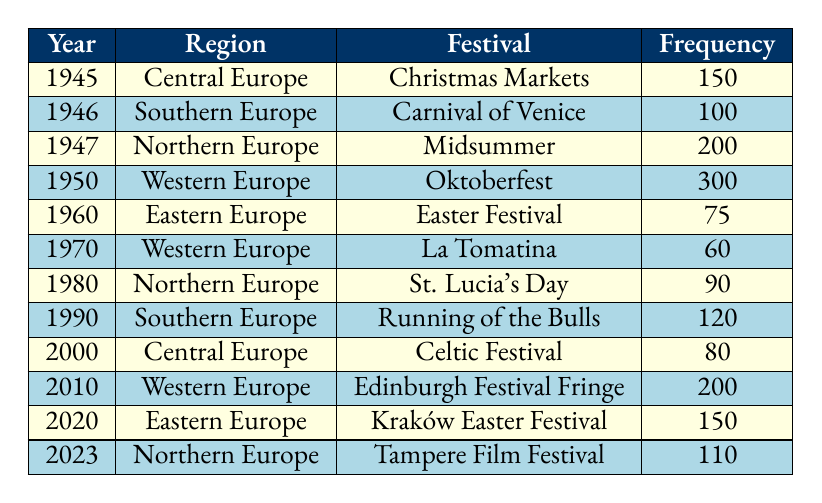What is the festival celebrated in 1950 in Western Europe? Referring to the table, in the year 1950 under the region Western Europe, the festival is noted as Oktoberfest.
Answer: Oktoberfest Which festival has the highest frequency in the table? By examining the frequency column, it's clear that Oktoberfest in 1950 has the highest frequency at 300.
Answer: Oktoberfest What is the sum of the frequencies of festivals in Southern Europe? The frequencies for Southern Europe are 100 (Carnival of Venice in 1946) and 120 (Running of the Bulls in 1990). Adding them gives 100 + 120 = 220.
Answer: 220 How many festivals have a frequency of 150 or more? The festivals with a frequency of 150 or more are Christmas Markets (150), Midsummer (200), Oktoberfest (300), Edinburgh Festival Fringe (200), and Kraków Easter Festival (150), making a total of 5.
Answer: 5 Is there a festival celebrated in Eastern Europe in the year 1960? According to the table, in 1960, the festival celebrated in Eastern Europe is Easter Festival with a frequency of 75.
Answer: Yes What is the average frequency of festivals celebrated in Northern Europe from the data? The frequencies for Northern Europe are 200 (Midsummer in 1947), 90 (St. Lucia's Day in 1980), and 110 (Tampere Film Festival in 2023). The sum of these frequencies is 200 + 90 + 110 = 400, and there are 3 data points, thus the average is 400 / 3 = 133.33.
Answer: 133.33 Which region has the festival with the lowest frequency? Checking the frequency column, Easter Festival in Eastern Europe in 1960 has the lowest frequency at 75.
Answer: Eastern Europe What is the difference between the highest and lowest frequencies in the table? The highest frequency is 300 (Oktoberfest) and the lowest is 60 (La Tomatina). The difference is 300 - 60 = 240.
Answer: 240 List the years in which festivals occurred in Central Europe. The table shows that festivals in Central Europe occurred in 1945 (Christmas Markets) and 2000 (Celtic Festival).
Answer: 1945, 2000 